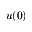Convert formula to latex. <formula><loc_0><loc_0><loc_500><loc_500>u ( 0 )</formula> 